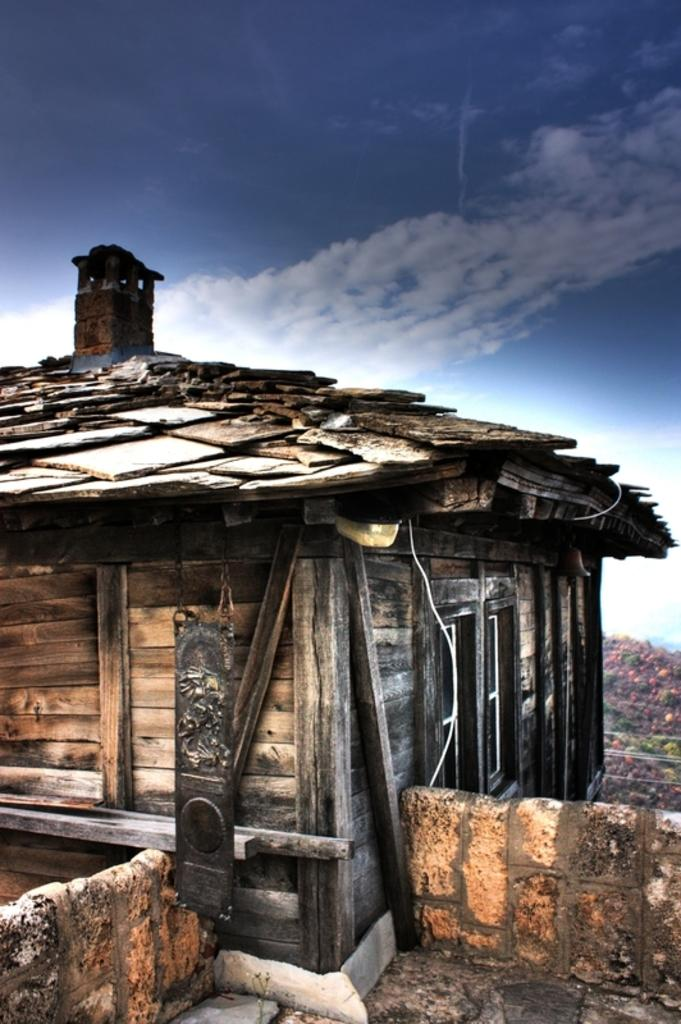What type of house is in the image? There is a wooden house in the image. What structure is also present in the image? There is a wall in the image. What natural feature can be seen in the background of the image? There is a mountain in the image. What is visible above the house and wall in the image? The sky is visible in the image. What type of plastic is covering the mountain in the image? There is no plastic covering the mountain in the image; it is a natural feature. 